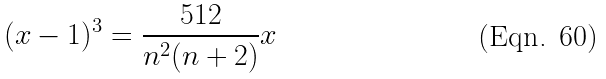<formula> <loc_0><loc_0><loc_500><loc_500>( x - 1 ) ^ { 3 } = \frac { 5 1 2 } { n ^ { 2 } ( n + 2 ) } x</formula> 